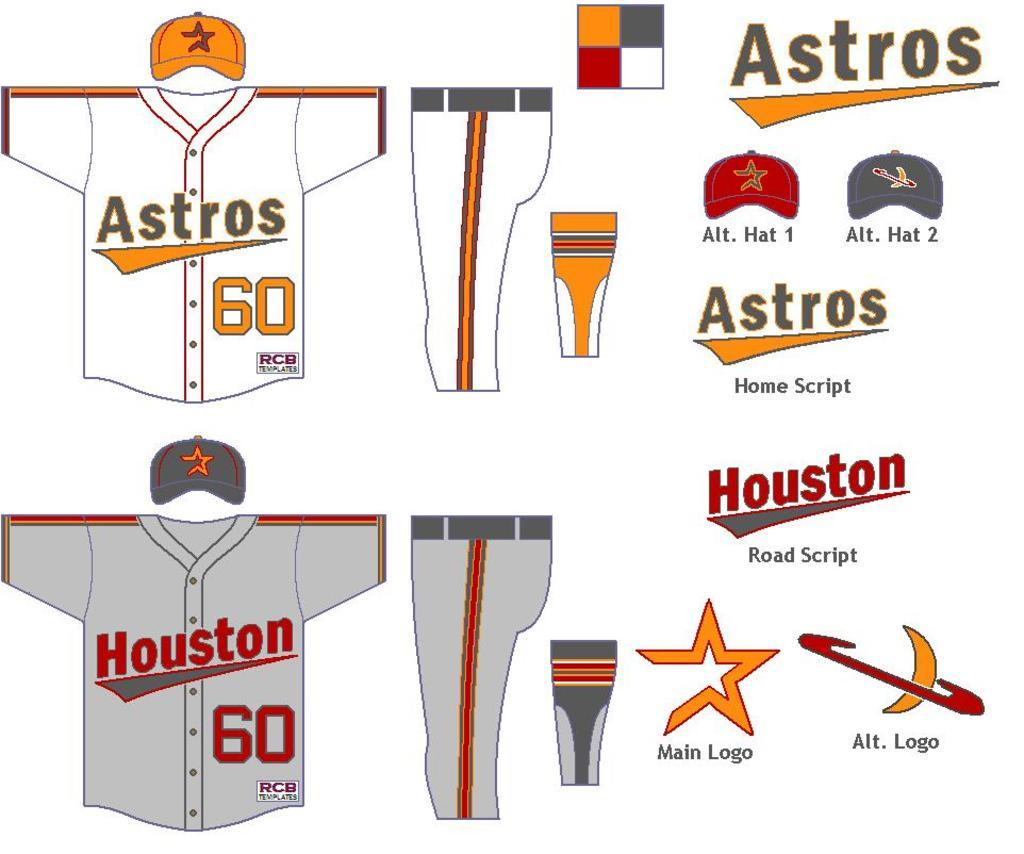<image>
Write a terse but informative summary of the picture. Houston Astros uniform shirts, pants and baseball caps. 